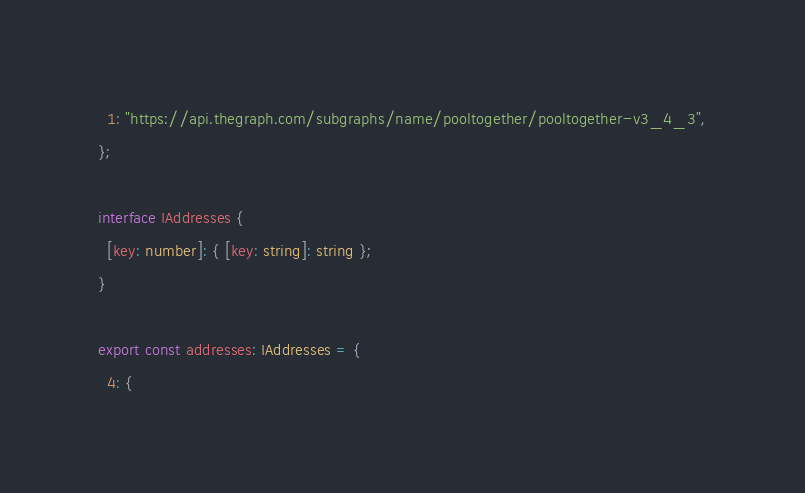Convert code to text. <code><loc_0><loc_0><loc_500><loc_500><_TypeScript_>  1: "https://api.thegraph.com/subgraphs/name/pooltogether/pooltogether-v3_4_3",
};

interface IAddresses {
  [key: number]: { [key: string]: string };
}

export const addresses: IAddresses = {
  4: {</code> 